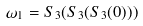Convert formula to latex. <formula><loc_0><loc_0><loc_500><loc_500>\omega _ { 1 } = S _ { 3 } ( S _ { 3 } ( S _ { 3 } ( 0 ) ) )</formula> 